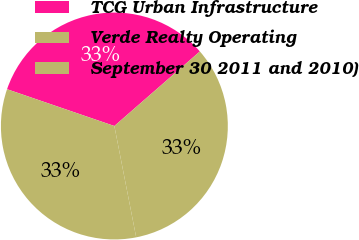Convert chart to OTSL. <chart><loc_0><loc_0><loc_500><loc_500><pie_chart><fcel>TCG Urban Infrastructure<fcel>Verde Realty Operating<fcel>September 30 2011 and 2010)<nl><fcel>33.33%<fcel>33.34%<fcel>33.33%<nl></chart> 